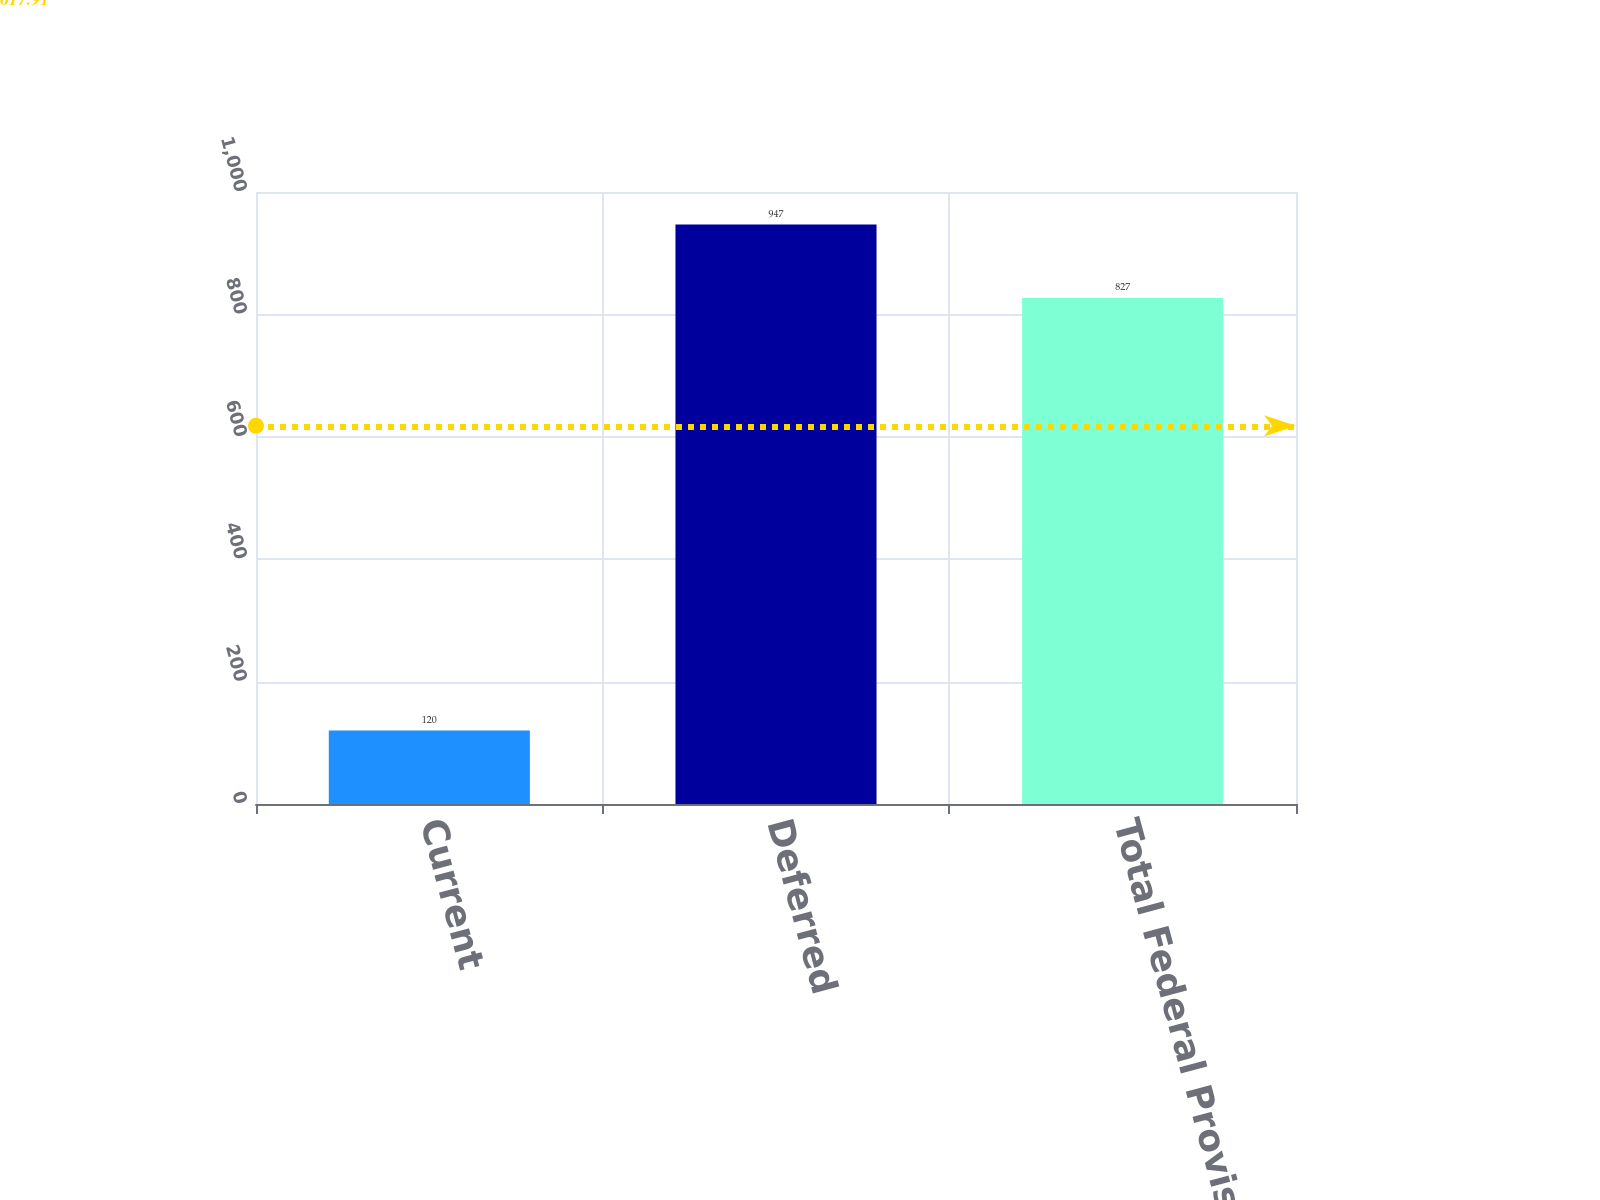<chart> <loc_0><loc_0><loc_500><loc_500><bar_chart><fcel>Current<fcel>Deferred<fcel>Total Federal Provision<nl><fcel>120<fcel>947<fcel>827<nl></chart> 